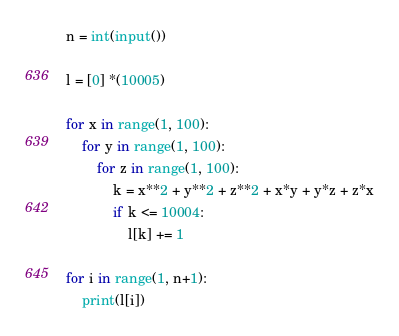Convert code to text. <code><loc_0><loc_0><loc_500><loc_500><_Python_>n = int(input())

l = [0] *(10005)

for x in range(1, 100):
    for y in range(1, 100):
        for z in range(1, 100):
            k = x**2 + y**2 + z**2 + x*y + y*z + z*x
            if k <= 10004:
                l[k] += 1

for i in range(1, n+1):
    print(l[i])</code> 